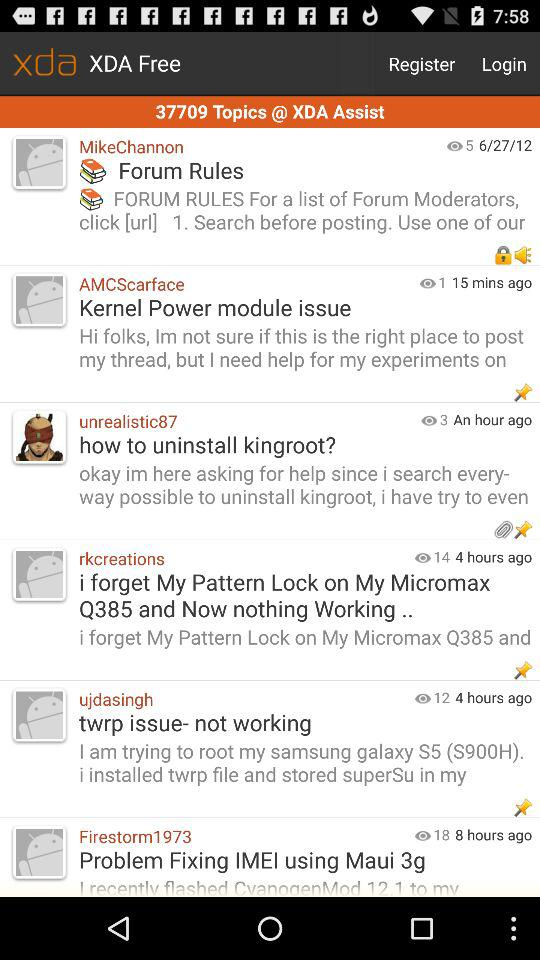At what time and on what day was "twrp issue- not working" posted?
When the provided information is insufficient, respond with <no answer>. <no answer> 